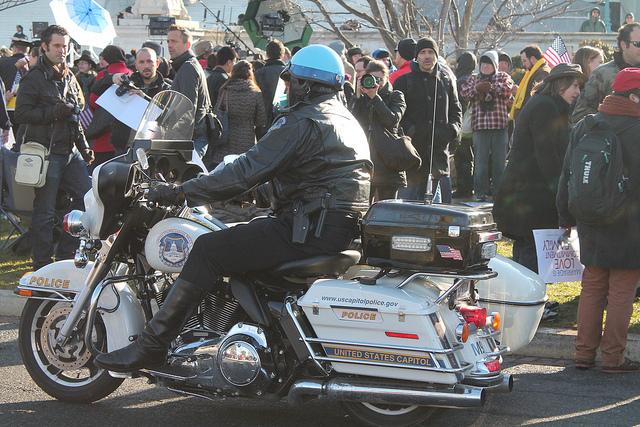Are these people cold?
Keep it brief. Yes. What color is the bike?
Answer briefly. White. Who is on the bike?
Short answer required. Police. How many people in the shot?
Concise answer only. 50. Do you see anyone wearing shorts?
Quick response, please. No. What city does the motorcycle cop work in?
Concise answer only. Washington dc. What is the man on?
Give a very brief answer. Motorcycle. What flag do you see?
Quick response, please. Usa. 